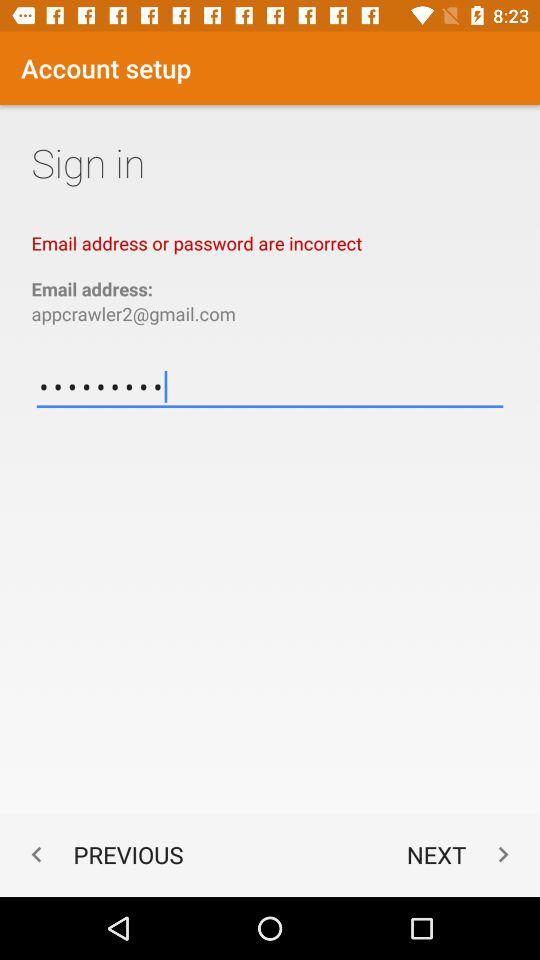What is the email address? The email address is appcrawler2@gmail.com. 